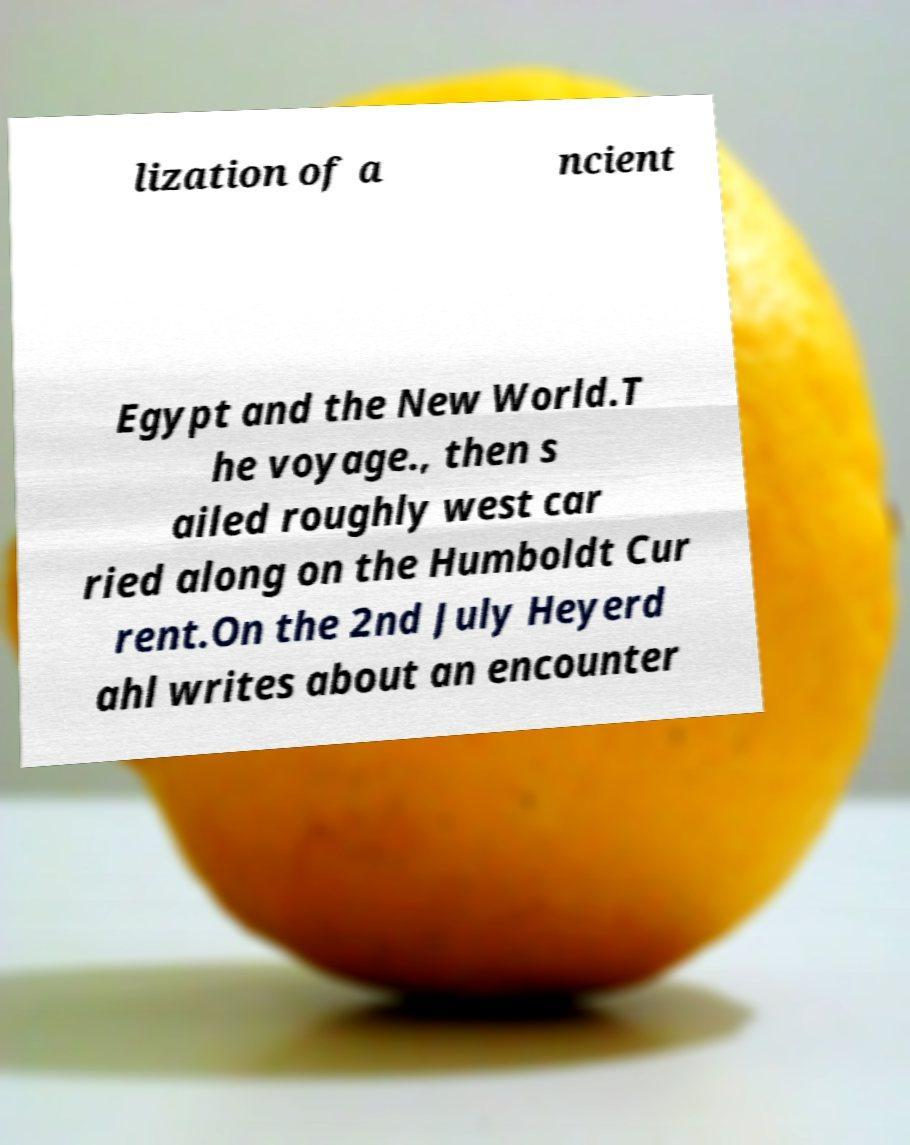Can you read and provide the text displayed in the image?This photo seems to have some interesting text. Can you extract and type it out for me? lization of a ncient Egypt and the New World.T he voyage., then s ailed roughly west car ried along on the Humboldt Cur rent.On the 2nd July Heyerd ahl writes about an encounter 